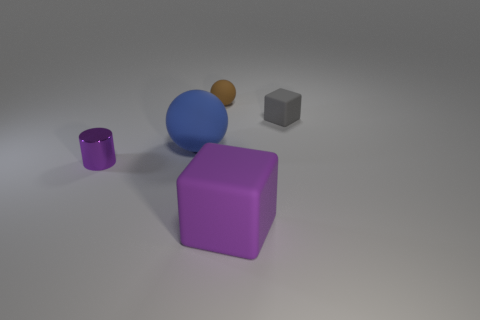Add 4 purple cylinders. How many objects exist? 9 Subtract all spheres. How many objects are left? 3 Subtract 0 green cylinders. How many objects are left? 5 Subtract all tiny blocks. Subtract all blue things. How many objects are left? 3 Add 3 blue things. How many blue things are left? 4 Add 4 purple shiny things. How many purple shiny things exist? 5 